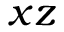<formula> <loc_0><loc_0><loc_500><loc_500>x z</formula> 